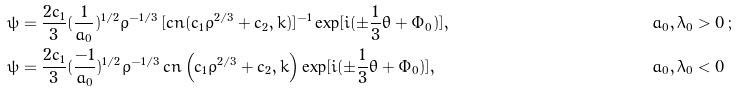<formula> <loc_0><loc_0><loc_500><loc_500>& \psi = \frac { 2 c _ { 1 } } { 3 } ( \frac { 1 } { a _ { 0 } } ) ^ { 1 / 2 } \rho ^ { - 1 / 3 } \, [ c n ( c _ { 1 } \rho ^ { 2 / 3 } + c _ { 2 } , k ) ] ^ { - 1 } \exp [ i ( \pm \frac { 1 } { 3 } \theta + \Phi _ { 0 } ) ] , \quad & & a _ { 0 } , \lambda _ { 0 } > 0 \, ; \\ & \psi = \frac { 2 c _ { 1 } } { 3 } ( \frac { - 1 } { a _ { 0 } } ) ^ { 1 / 2 } \rho ^ { - 1 / 3 } \, c n \left ( c _ { 1 } \rho ^ { 2 / 3 } + c _ { 2 } , k \right ) \exp [ i ( \pm \frac { 1 } { 3 } \theta + \Phi _ { 0 } ) ] , \quad & & a _ { 0 } , \lambda _ { 0 } < 0</formula> 